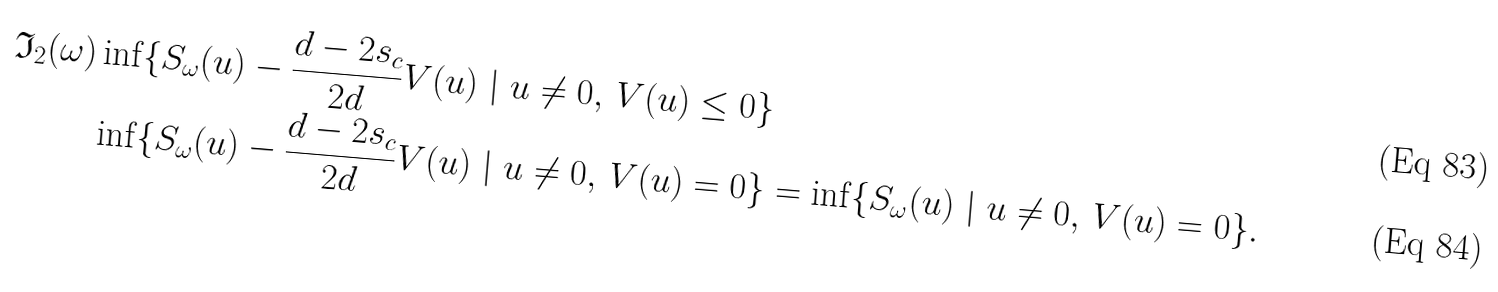Convert formula to latex. <formula><loc_0><loc_0><loc_500><loc_500>\mathfrak { I } _ { 2 } ( \omega ) & \inf \{ S _ { \omega } ( { u } ) - \frac { d - 2 s _ { c } } { 2 d } V ( { u } ) \ | \ { u } \neq 0 , \, V ( { u } ) \leq 0 \} \\ & \inf \{ S _ { \omega } ( { u } ) - \frac { d - 2 s _ { c } } { 2 d } V ( { u } ) \ | \ { u } \neq 0 , \, V ( { u } ) = 0 \} = \inf \{ S _ { \omega } ( { u } ) \ | \ { u } \neq 0 , \, V ( { u } ) = 0 \} .</formula> 